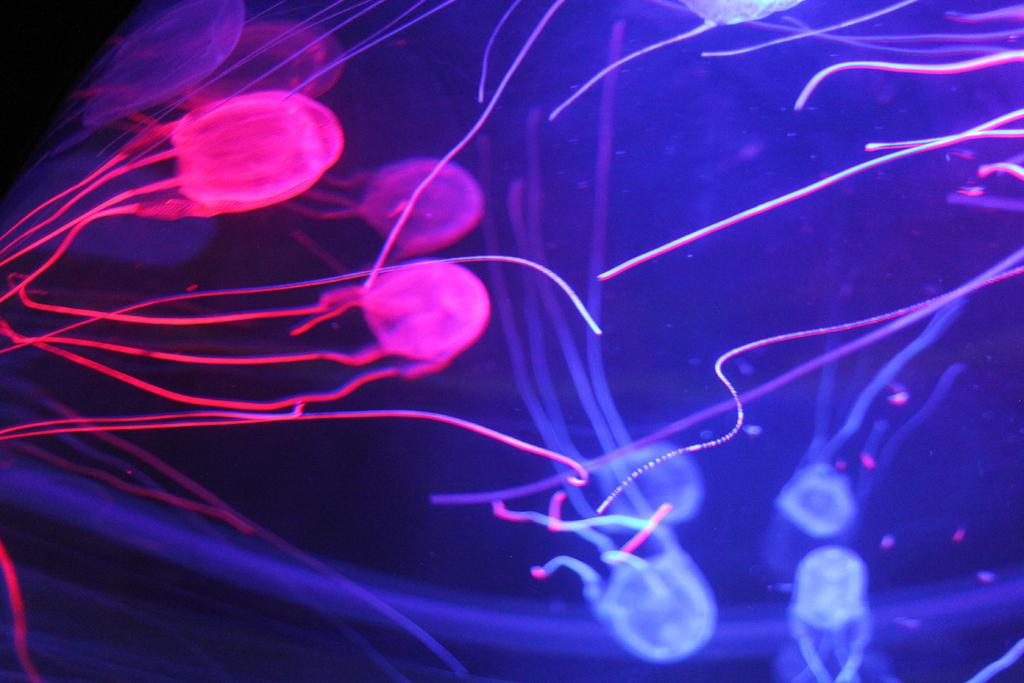What type of subject matter is depicted in the image? The image appears to depict microorganisms or a microscopic view. Can you describe the size of the objects in the image? The objects in the image are likely very small, as they are depicted in a microscopic view. What might be the purpose of this image? The purpose of the image could be for scientific or educational purposes, as it provides a close-up view of microorganisms. What type of vacation destination is shown in the image? There is no vacation destination present in the image; it depicts microorganisms or a microscopic view. Can you tell me how many beans are visible in the image? There are no beans present in the image; it depicts microorganisms or a microscopic view. 